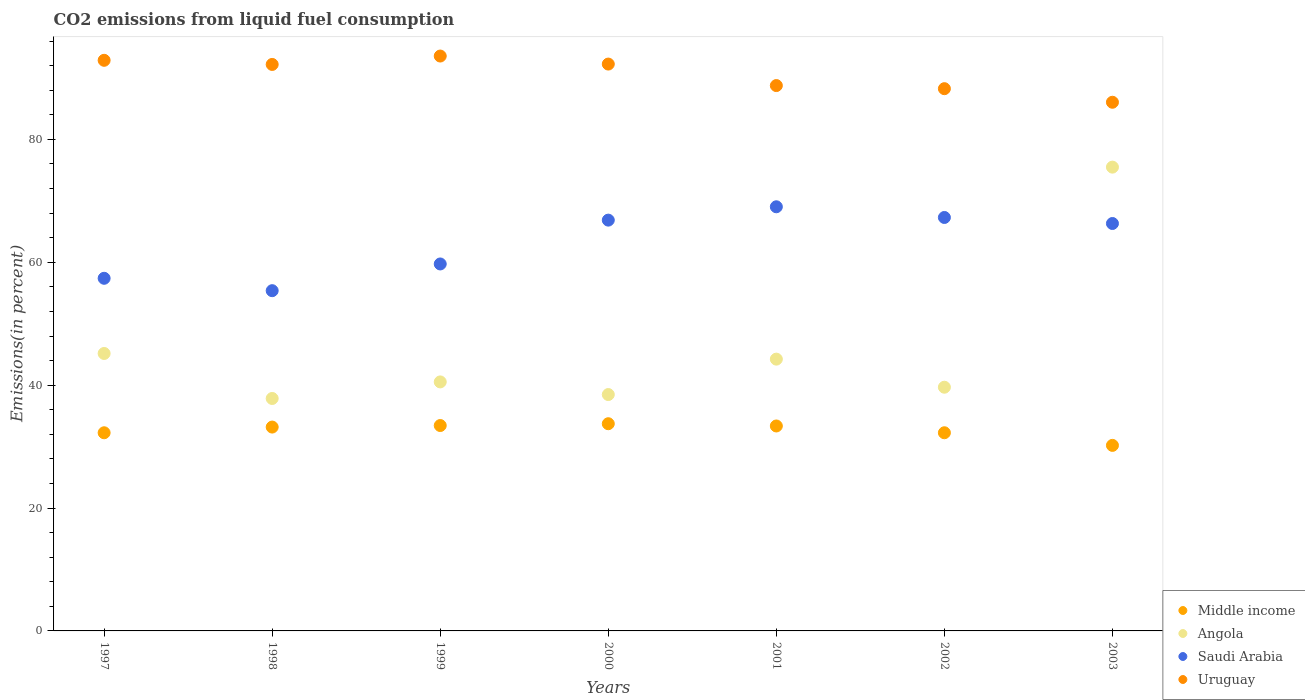How many different coloured dotlines are there?
Provide a succinct answer. 4. What is the total CO2 emitted in Uruguay in 1997?
Make the answer very short. 92.87. Across all years, what is the maximum total CO2 emitted in Angola?
Provide a succinct answer. 75.49. Across all years, what is the minimum total CO2 emitted in Angola?
Keep it short and to the point. 37.83. In which year was the total CO2 emitted in Middle income minimum?
Offer a terse response. 2003. What is the total total CO2 emitted in Angola in the graph?
Keep it short and to the point. 321.37. What is the difference between the total CO2 emitted in Saudi Arabia in 1997 and that in 1998?
Provide a succinct answer. 2.02. What is the difference between the total CO2 emitted in Angola in 1998 and the total CO2 emitted in Uruguay in 2003?
Your response must be concise. -48.21. What is the average total CO2 emitted in Uruguay per year?
Offer a terse response. 90.57. In the year 1998, what is the difference between the total CO2 emitted in Middle income and total CO2 emitted in Angola?
Give a very brief answer. -4.65. In how many years, is the total CO2 emitted in Uruguay greater than 80 %?
Your response must be concise. 7. What is the ratio of the total CO2 emitted in Middle income in 1998 to that in 2001?
Make the answer very short. 0.99. Is the difference between the total CO2 emitted in Middle income in 1998 and 2000 greater than the difference between the total CO2 emitted in Angola in 1998 and 2000?
Offer a very short reply. Yes. What is the difference between the highest and the second highest total CO2 emitted in Uruguay?
Offer a terse response. 0.69. What is the difference between the highest and the lowest total CO2 emitted in Uruguay?
Your answer should be compact. 7.52. In how many years, is the total CO2 emitted in Angola greater than the average total CO2 emitted in Angola taken over all years?
Your answer should be compact. 1. Is the sum of the total CO2 emitted in Angola in 1997 and 2001 greater than the maximum total CO2 emitted in Uruguay across all years?
Your answer should be very brief. No. Is the total CO2 emitted in Saudi Arabia strictly greater than the total CO2 emitted in Angola over the years?
Offer a very short reply. No. How many dotlines are there?
Ensure brevity in your answer.  4. How many years are there in the graph?
Ensure brevity in your answer.  7. What is the difference between two consecutive major ticks on the Y-axis?
Provide a succinct answer. 20. Are the values on the major ticks of Y-axis written in scientific E-notation?
Make the answer very short. No. Does the graph contain any zero values?
Ensure brevity in your answer.  No. Where does the legend appear in the graph?
Your response must be concise. Bottom right. How are the legend labels stacked?
Your answer should be compact. Vertical. What is the title of the graph?
Keep it short and to the point. CO2 emissions from liquid fuel consumption. What is the label or title of the Y-axis?
Keep it short and to the point. Emissions(in percent). What is the Emissions(in percent) of Middle income in 1997?
Your response must be concise. 32.25. What is the Emissions(in percent) of Angola in 1997?
Make the answer very short. 45.16. What is the Emissions(in percent) in Saudi Arabia in 1997?
Make the answer very short. 57.39. What is the Emissions(in percent) in Uruguay in 1997?
Provide a short and direct response. 92.87. What is the Emissions(in percent) in Middle income in 1998?
Make the answer very short. 33.18. What is the Emissions(in percent) in Angola in 1998?
Ensure brevity in your answer.  37.83. What is the Emissions(in percent) in Saudi Arabia in 1998?
Keep it short and to the point. 55.38. What is the Emissions(in percent) of Uruguay in 1998?
Ensure brevity in your answer.  92.2. What is the Emissions(in percent) in Middle income in 1999?
Provide a short and direct response. 33.43. What is the Emissions(in percent) in Angola in 1999?
Offer a terse response. 40.53. What is the Emissions(in percent) in Saudi Arabia in 1999?
Keep it short and to the point. 59.73. What is the Emissions(in percent) of Uruguay in 1999?
Ensure brevity in your answer.  93.57. What is the Emissions(in percent) in Middle income in 2000?
Offer a very short reply. 33.72. What is the Emissions(in percent) of Angola in 2000?
Your response must be concise. 38.47. What is the Emissions(in percent) in Saudi Arabia in 2000?
Your answer should be compact. 66.86. What is the Emissions(in percent) of Uruguay in 2000?
Your response must be concise. 92.26. What is the Emissions(in percent) of Middle income in 2001?
Offer a terse response. 33.36. What is the Emissions(in percent) in Angola in 2001?
Provide a short and direct response. 44.24. What is the Emissions(in percent) in Saudi Arabia in 2001?
Make the answer very short. 69.03. What is the Emissions(in percent) in Uruguay in 2001?
Your answer should be compact. 88.76. What is the Emissions(in percent) of Middle income in 2002?
Your response must be concise. 32.25. What is the Emissions(in percent) of Angola in 2002?
Keep it short and to the point. 39.66. What is the Emissions(in percent) of Saudi Arabia in 2002?
Provide a succinct answer. 67.29. What is the Emissions(in percent) of Uruguay in 2002?
Provide a succinct answer. 88.25. What is the Emissions(in percent) in Middle income in 2003?
Offer a very short reply. 30.2. What is the Emissions(in percent) in Angola in 2003?
Keep it short and to the point. 75.49. What is the Emissions(in percent) of Saudi Arabia in 2003?
Your answer should be very brief. 66.31. What is the Emissions(in percent) in Uruguay in 2003?
Your answer should be very brief. 86.04. Across all years, what is the maximum Emissions(in percent) in Middle income?
Your response must be concise. 33.72. Across all years, what is the maximum Emissions(in percent) of Angola?
Your response must be concise. 75.49. Across all years, what is the maximum Emissions(in percent) of Saudi Arabia?
Your response must be concise. 69.03. Across all years, what is the maximum Emissions(in percent) in Uruguay?
Provide a succinct answer. 93.57. Across all years, what is the minimum Emissions(in percent) in Middle income?
Your answer should be compact. 30.2. Across all years, what is the minimum Emissions(in percent) of Angola?
Provide a succinct answer. 37.83. Across all years, what is the minimum Emissions(in percent) in Saudi Arabia?
Offer a very short reply. 55.38. Across all years, what is the minimum Emissions(in percent) of Uruguay?
Offer a very short reply. 86.04. What is the total Emissions(in percent) of Middle income in the graph?
Offer a very short reply. 228.39. What is the total Emissions(in percent) of Angola in the graph?
Offer a terse response. 321.37. What is the total Emissions(in percent) of Saudi Arabia in the graph?
Give a very brief answer. 441.99. What is the total Emissions(in percent) of Uruguay in the graph?
Provide a short and direct response. 633.96. What is the difference between the Emissions(in percent) in Middle income in 1997 and that in 1998?
Give a very brief answer. -0.93. What is the difference between the Emissions(in percent) of Angola in 1997 and that in 1998?
Your response must be concise. 7.32. What is the difference between the Emissions(in percent) in Saudi Arabia in 1997 and that in 1998?
Provide a short and direct response. 2.02. What is the difference between the Emissions(in percent) of Uruguay in 1997 and that in 1998?
Keep it short and to the point. 0.67. What is the difference between the Emissions(in percent) in Middle income in 1997 and that in 1999?
Give a very brief answer. -1.18. What is the difference between the Emissions(in percent) in Angola in 1997 and that in 1999?
Provide a succinct answer. 4.63. What is the difference between the Emissions(in percent) in Saudi Arabia in 1997 and that in 1999?
Offer a very short reply. -2.33. What is the difference between the Emissions(in percent) in Uruguay in 1997 and that in 1999?
Provide a succinct answer. -0.69. What is the difference between the Emissions(in percent) of Middle income in 1997 and that in 2000?
Provide a succinct answer. -1.47. What is the difference between the Emissions(in percent) in Angola in 1997 and that in 2000?
Your answer should be compact. 6.69. What is the difference between the Emissions(in percent) of Saudi Arabia in 1997 and that in 2000?
Your response must be concise. -9.47. What is the difference between the Emissions(in percent) in Uruguay in 1997 and that in 2000?
Make the answer very short. 0.61. What is the difference between the Emissions(in percent) in Middle income in 1997 and that in 2001?
Provide a short and direct response. -1.1. What is the difference between the Emissions(in percent) of Angola in 1997 and that in 2001?
Provide a succinct answer. 0.92. What is the difference between the Emissions(in percent) of Saudi Arabia in 1997 and that in 2001?
Your response must be concise. -11.64. What is the difference between the Emissions(in percent) of Uruguay in 1997 and that in 2001?
Your response must be concise. 4.11. What is the difference between the Emissions(in percent) of Middle income in 1997 and that in 2002?
Offer a terse response. -0. What is the difference between the Emissions(in percent) in Angola in 1997 and that in 2002?
Make the answer very short. 5.49. What is the difference between the Emissions(in percent) in Saudi Arabia in 1997 and that in 2002?
Give a very brief answer. -9.9. What is the difference between the Emissions(in percent) of Uruguay in 1997 and that in 2002?
Your answer should be very brief. 4.62. What is the difference between the Emissions(in percent) of Middle income in 1997 and that in 2003?
Offer a terse response. 2.05. What is the difference between the Emissions(in percent) in Angola in 1997 and that in 2003?
Make the answer very short. -30.33. What is the difference between the Emissions(in percent) of Saudi Arabia in 1997 and that in 2003?
Provide a short and direct response. -8.92. What is the difference between the Emissions(in percent) of Uruguay in 1997 and that in 2003?
Keep it short and to the point. 6.83. What is the difference between the Emissions(in percent) in Middle income in 1998 and that in 1999?
Your answer should be compact. -0.25. What is the difference between the Emissions(in percent) in Angola in 1998 and that in 1999?
Keep it short and to the point. -2.7. What is the difference between the Emissions(in percent) of Saudi Arabia in 1998 and that in 1999?
Provide a short and direct response. -4.35. What is the difference between the Emissions(in percent) in Uruguay in 1998 and that in 1999?
Ensure brevity in your answer.  -1.37. What is the difference between the Emissions(in percent) in Middle income in 1998 and that in 2000?
Offer a very short reply. -0.55. What is the difference between the Emissions(in percent) in Angola in 1998 and that in 2000?
Ensure brevity in your answer.  -0.64. What is the difference between the Emissions(in percent) in Saudi Arabia in 1998 and that in 2000?
Offer a very short reply. -11.48. What is the difference between the Emissions(in percent) of Uruguay in 1998 and that in 2000?
Make the answer very short. -0.06. What is the difference between the Emissions(in percent) of Middle income in 1998 and that in 2001?
Your answer should be very brief. -0.18. What is the difference between the Emissions(in percent) in Angola in 1998 and that in 2001?
Offer a very short reply. -6.4. What is the difference between the Emissions(in percent) in Saudi Arabia in 1998 and that in 2001?
Make the answer very short. -13.65. What is the difference between the Emissions(in percent) of Uruguay in 1998 and that in 2001?
Make the answer very short. 3.44. What is the difference between the Emissions(in percent) in Middle income in 1998 and that in 2002?
Your response must be concise. 0.93. What is the difference between the Emissions(in percent) in Angola in 1998 and that in 2002?
Provide a succinct answer. -1.83. What is the difference between the Emissions(in percent) of Saudi Arabia in 1998 and that in 2002?
Your answer should be compact. -11.91. What is the difference between the Emissions(in percent) in Uruguay in 1998 and that in 2002?
Give a very brief answer. 3.94. What is the difference between the Emissions(in percent) of Middle income in 1998 and that in 2003?
Provide a succinct answer. 2.98. What is the difference between the Emissions(in percent) of Angola in 1998 and that in 2003?
Your answer should be very brief. -37.65. What is the difference between the Emissions(in percent) in Saudi Arabia in 1998 and that in 2003?
Ensure brevity in your answer.  -10.93. What is the difference between the Emissions(in percent) in Uruguay in 1998 and that in 2003?
Give a very brief answer. 6.15. What is the difference between the Emissions(in percent) of Middle income in 1999 and that in 2000?
Your answer should be compact. -0.29. What is the difference between the Emissions(in percent) of Angola in 1999 and that in 2000?
Your answer should be very brief. 2.06. What is the difference between the Emissions(in percent) of Saudi Arabia in 1999 and that in 2000?
Offer a terse response. -7.13. What is the difference between the Emissions(in percent) in Uruguay in 1999 and that in 2000?
Make the answer very short. 1.31. What is the difference between the Emissions(in percent) of Middle income in 1999 and that in 2001?
Give a very brief answer. 0.07. What is the difference between the Emissions(in percent) in Angola in 1999 and that in 2001?
Your response must be concise. -3.71. What is the difference between the Emissions(in percent) in Saudi Arabia in 1999 and that in 2001?
Give a very brief answer. -9.31. What is the difference between the Emissions(in percent) of Uruguay in 1999 and that in 2001?
Give a very brief answer. 4.81. What is the difference between the Emissions(in percent) of Middle income in 1999 and that in 2002?
Provide a short and direct response. 1.18. What is the difference between the Emissions(in percent) in Angola in 1999 and that in 2002?
Offer a very short reply. 0.86. What is the difference between the Emissions(in percent) of Saudi Arabia in 1999 and that in 2002?
Keep it short and to the point. -7.57. What is the difference between the Emissions(in percent) in Uruguay in 1999 and that in 2002?
Provide a short and direct response. 5.31. What is the difference between the Emissions(in percent) in Middle income in 1999 and that in 2003?
Offer a terse response. 3.23. What is the difference between the Emissions(in percent) in Angola in 1999 and that in 2003?
Provide a succinct answer. -34.96. What is the difference between the Emissions(in percent) in Saudi Arabia in 1999 and that in 2003?
Keep it short and to the point. -6.59. What is the difference between the Emissions(in percent) in Uruguay in 1999 and that in 2003?
Provide a short and direct response. 7.52. What is the difference between the Emissions(in percent) of Middle income in 2000 and that in 2001?
Keep it short and to the point. 0.37. What is the difference between the Emissions(in percent) in Angola in 2000 and that in 2001?
Your response must be concise. -5.76. What is the difference between the Emissions(in percent) in Saudi Arabia in 2000 and that in 2001?
Keep it short and to the point. -2.17. What is the difference between the Emissions(in percent) of Uruguay in 2000 and that in 2001?
Ensure brevity in your answer.  3.5. What is the difference between the Emissions(in percent) in Middle income in 2000 and that in 2002?
Provide a short and direct response. 1.47. What is the difference between the Emissions(in percent) of Angola in 2000 and that in 2002?
Give a very brief answer. -1.19. What is the difference between the Emissions(in percent) in Saudi Arabia in 2000 and that in 2002?
Provide a succinct answer. -0.43. What is the difference between the Emissions(in percent) of Uruguay in 2000 and that in 2002?
Make the answer very short. 4.01. What is the difference between the Emissions(in percent) of Middle income in 2000 and that in 2003?
Your answer should be very brief. 3.53. What is the difference between the Emissions(in percent) of Angola in 2000 and that in 2003?
Offer a very short reply. -37.02. What is the difference between the Emissions(in percent) in Saudi Arabia in 2000 and that in 2003?
Offer a terse response. 0.55. What is the difference between the Emissions(in percent) of Uruguay in 2000 and that in 2003?
Your answer should be compact. 6.22. What is the difference between the Emissions(in percent) of Middle income in 2001 and that in 2002?
Keep it short and to the point. 1.1. What is the difference between the Emissions(in percent) of Angola in 2001 and that in 2002?
Offer a terse response. 4.57. What is the difference between the Emissions(in percent) of Saudi Arabia in 2001 and that in 2002?
Make the answer very short. 1.74. What is the difference between the Emissions(in percent) in Uruguay in 2001 and that in 2002?
Give a very brief answer. 0.51. What is the difference between the Emissions(in percent) of Middle income in 2001 and that in 2003?
Give a very brief answer. 3.16. What is the difference between the Emissions(in percent) in Angola in 2001 and that in 2003?
Make the answer very short. -31.25. What is the difference between the Emissions(in percent) of Saudi Arabia in 2001 and that in 2003?
Offer a very short reply. 2.72. What is the difference between the Emissions(in percent) of Uruguay in 2001 and that in 2003?
Your response must be concise. 2.72. What is the difference between the Emissions(in percent) of Middle income in 2002 and that in 2003?
Make the answer very short. 2.05. What is the difference between the Emissions(in percent) in Angola in 2002 and that in 2003?
Provide a succinct answer. -35.82. What is the difference between the Emissions(in percent) of Saudi Arabia in 2002 and that in 2003?
Offer a very short reply. 0.98. What is the difference between the Emissions(in percent) of Uruguay in 2002 and that in 2003?
Your answer should be very brief. 2.21. What is the difference between the Emissions(in percent) of Middle income in 1997 and the Emissions(in percent) of Angola in 1998?
Ensure brevity in your answer.  -5.58. What is the difference between the Emissions(in percent) of Middle income in 1997 and the Emissions(in percent) of Saudi Arabia in 1998?
Ensure brevity in your answer.  -23.13. What is the difference between the Emissions(in percent) of Middle income in 1997 and the Emissions(in percent) of Uruguay in 1998?
Give a very brief answer. -59.95. What is the difference between the Emissions(in percent) of Angola in 1997 and the Emissions(in percent) of Saudi Arabia in 1998?
Provide a succinct answer. -10.22. What is the difference between the Emissions(in percent) in Angola in 1997 and the Emissions(in percent) in Uruguay in 1998?
Ensure brevity in your answer.  -47.04. What is the difference between the Emissions(in percent) in Saudi Arabia in 1997 and the Emissions(in percent) in Uruguay in 1998?
Provide a succinct answer. -34.81. What is the difference between the Emissions(in percent) in Middle income in 1997 and the Emissions(in percent) in Angola in 1999?
Provide a short and direct response. -8.28. What is the difference between the Emissions(in percent) of Middle income in 1997 and the Emissions(in percent) of Saudi Arabia in 1999?
Keep it short and to the point. -27.47. What is the difference between the Emissions(in percent) of Middle income in 1997 and the Emissions(in percent) of Uruguay in 1999?
Your answer should be compact. -61.31. What is the difference between the Emissions(in percent) in Angola in 1997 and the Emissions(in percent) in Saudi Arabia in 1999?
Make the answer very short. -14.57. What is the difference between the Emissions(in percent) of Angola in 1997 and the Emissions(in percent) of Uruguay in 1999?
Ensure brevity in your answer.  -48.41. What is the difference between the Emissions(in percent) of Saudi Arabia in 1997 and the Emissions(in percent) of Uruguay in 1999?
Ensure brevity in your answer.  -36.17. What is the difference between the Emissions(in percent) in Middle income in 1997 and the Emissions(in percent) in Angola in 2000?
Provide a short and direct response. -6.22. What is the difference between the Emissions(in percent) of Middle income in 1997 and the Emissions(in percent) of Saudi Arabia in 2000?
Offer a terse response. -34.61. What is the difference between the Emissions(in percent) in Middle income in 1997 and the Emissions(in percent) in Uruguay in 2000?
Ensure brevity in your answer.  -60.01. What is the difference between the Emissions(in percent) of Angola in 1997 and the Emissions(in percent) of Saudi Arabia in 2000?
Provide a succinct answer. -21.7. What is the difference between the Emissions(in percent) of Angola in 1997 and the Emissions(in percent) of Uruguay in 2000?
Keep it short and to the point. -47.1. What is the difference between the Emissions(in percent) in Saudi Arabia in 1997 and the Emissions(in percent) in Uruguay in 2000?
Your answer should be very brief. -34.87. What is the difference between the Emissions(in percent) in Middle income in 1997 and the Emissions(in percent) in Angola in 2001?
Your response must be concise. -11.98. What is the difference between the Emissions(in percent) of Middle income in 1997 and the Emissions(in percent) of Saudi Arabia in 2001?
Your answer should be very brief. -36.78. What is the difference between the Emissions(in percent) in Middle income in 1997 and the Emissions(in percent) in Uruguay in 2001?
Your answer should be compact. -56.51. What is the difference between the Emissions(in percent) of Angola in 1997 and the Emissions(in percent) of Saudi Arabia in 2001?
Keep it short and to the point. -23.88. What is the difference between the Emissions(in percent) of Angola in 1997 and the Emissions(in percent) of Uruguay in 2001?
Offer a terse response. -43.6. What is the difference between the Emissions(in percent) of Saudi Arabia in 1997 and the Emissions(in percent) of Uruguay in 2001?
Your answer should be compact. -31.37. What is the difference between the Emissions(in percent) of Middle income in 1997 and the Emissions(in percent) of Angola in 2002?
Provide a succinct answer. -7.41. What is the difference between the Emissions(in percent) of Middle income in 1997 and the Emissions(in percent) of Saudi Arabia in 2002?
Provide a short and direct response. -35.04. What is the difference between the Emissions(in percent) of Middle income in 1997 and the Emissions(in percent) of Uruguay in 2002?
Your response must be concise. -56. What is the difference between the Emissions(in percent) in Angola in 1997 and the Emissions(in percent) in Saudi Arabia in 2002?
Your response must be concise. -22.13. What is the difference between the Emissions(in percent) of Angola in 1997 and the Emissions(in percent) of Uruguay in 2002?
Provide a succinct answer. -43.1. What is the difference between the Emissions(in percent) of Saudi Arabia in 1997 and the Emissions(in percent) of Uruguay in 2002?
Offer a terse response. -30.86. What is the difference between the Emissions(in percent) in Middle income in 1997 and the Emissions(in percent) in Angola in 2003?
Offer a very short reply. -43.23. What is the difference between the Emissions(in percent) of Middle income in 1997 and the Emissions(in percent) of Saudi Arabia in 2003?
Your response must be concise. -34.06. What is the difference between the Emissions(in percent) of Middle income in 1997 and the Emissions(in percent) of Uruguay in 2003?
Make the answer very short. -53.79. What is the difference between the Emissions(in percent) in Angola in 1997 and the Emissions(in percent) in Saudi Arabia in 2003?
Provide a short and direct response. -21.15. What is the difference between the Emissions(in percent) of Angola in 1997 and the Emissions(in percent) of Uruguay in 2003?
Your response must be concise. -40.89. What is the difference between the Emissions(in percent) in Saudi Arabia in 1997 and the Emissions(in percent) in Uruguay in 2003?
Keep it short and to the point. -28.65. What is the difference between the Emissions(in percent) of Middle income in 1998 and the Emissions(in percent) of Angola in 1999?
Offer a very short reply. -7.35. What is the difference between the Emissions(in percent) of Middle income in 1998 and the Emissions(in percent) of Saudi Arabia in 1999?
Your answer should be very brief. -26.55. What is the difference between the Emissions(in percent) in Middle income in 1998 and the Emissions(in percent) in Uruguay in 1999?
Ensure brevity in your answer.  -60.39. What is the difference between the Emissions(in percent) in Angola in 1998 and the Emissions(in percent) in Saudi Arabia in 1999?
Provide a succinct answer. -21.89. What is the difference between the Emissions(in percent) of Angola in 1998 and the Emissions(in percent) of Uruguay in 1999?
Offer a very short reply. -55.73. What is the difference between the Emissions(in percent) of Saudi Arabia in 1998 and the Emissions(in percent) of Uruguay in 1999?
Offer a very short reply. -38.19. What is the difference between the Emissions(in percent) in Middle income in 1998 and the Emissions(in percent) in Angola in 2000?
Give a very brief answer. -5.29. What is the difference between the Emissions(in percent) of Middle income in 1998 and the Emissions(in percent) of Saudi Arabia in 2000?
Offer a terse response. -33.68. What is the difference between the Emissions(in percent) in Middle income in 1998 and the Emissions(in percent) in Uruguay in 2000?
Give a very brief answer. -59.08. What is the difference between the Emissions(in percent) of Angola in 1998 and the Emissions(in percent) of Saudi Arabia in 2000?
Offer a terse response. -29.03. What is the difference between the Emissions(in percent) in Angola in 1998 and the Emissions(in percent) in Uruguay in 2000?
Keep it short and to the point. -54.43. What is the difference between the Emissions(in percent) of Saudi Arabia in 1998 and the Emissions(in percent) of Uruguay in 2000?
Your answer should be compact. -36.88. What is the difference between the Emissions(in percent) of Middle income in 1998 and the Emissions(in percent) of Angola in 2001?
Your answer should be very brief. -11.06. What is the difference between the Emissions(in percent) of Middle income in 1998 and the Emissions(in percent) of Saudi Arabia in 2001?
Give a very brief answer. -35.85. What is the difference between the Emissions(in percent) of Middle income in 1998 and the Emissions(in percent) of Uruguay in 2001?
Offer a terse response. -55.58. What is the difference between the Emissions(in percent) in Angola in 1998 and the Emissions(in percent) in Saudi Arabia in 2001?
Your response must be concise. -31.2. What is the difference between the Emissions(in percent) of Angola in 1998 and the Emissions(in percent) of Uruguay in 2001?
Ensure brevity in your answer.  -50.93. What is the difference between the Emissions(in percent) in Saudi Arabia in 1998 and the Emissions(in percent) in Uruguay in 2001?
Your response must be concise. -33.38. What is the difference between the Emissions(in percent) of Middle income in 1998 and the Emissions(in percent) of Angola in 2002?
Your response must be concise. -6.49. What is the difference between the Emissions(in percent) of Middle income in 1998 and the Emissions(in percent) of Saudi Arabia in 2002?
Offer a very short reply. -34.11. What is the difference between the Emissions(in percent) in Middle income in 1998 and the Emissions(in percent) in Uruguay in 2002?
Your answer should be compact. -55.08. What is the difference between the Emissions(in percent) of Angola in 1998 and the Emissions(in percent) of Saudi Arabia in 2002?
Your answer should be compact. -29.46. What is the difference between the Emissions(in percent) in Angola in 1998 and the Emissions(in percent) in Uruguay in 2002?
Ensure brevity in your answer.  -50.42. What is the difference between the Emissions(in percent) in Saudi Arabia in 1998 and the Emissions(in percent) in Uruguay in 2002?
Your answer should be very brief. -32.88. What is the difference between the Emissions(in percent) of Middle income in 1998 and the Emissions(in percent) of Angola in 2003?
Offer a very short reply. -42.31. What is the difference between the Emissions(in percent) in Middle income in 1998 and the Emissions(in percent) in Saudi Arabia in 2003?
Give a very brief answer. -33.13. What is the difference between the Emissions(in percent) in Middle income in 1998 and the Emissions(in percent) in Uruguay in 2003?
Keep it short and to the point. -52.87. What is the difference between the Emissions(in percent) of Angola in 1998 and the Emissions(in percent) of Saudi Arabia in 2003?
Provide a succinct answer. -28.48. What is the difference between the Emissions(in percent) of Angola in 1998 and the Emissions(in percent) of Uruguay in 2003?
Your answer should be very brief. -48.21. What is the difference between the Emissions(in percent) of Saudi Arabia in 1998 and the Emissions(in percent) of Uruguay in 2003?
Keep it short and to the point. -30.67. What is the difference between the Emissions(in percent) in Middle income in 1999 and the Emissions(in percent) in Angola in 2000?
Your response must be concise. -5.04. What is the difference between the Emissions(in percent) in Middle income in 1999 and the Emissions(in percent) in Saudi Arabia in 2000?
Make the answer very short. -33.43. What is the difference between the Emissions(in percent) in Middle income in 1999 and the Emissions(in percent) in Uruguay in 2000?
Give a very brief answer. -58.83. What is the difference between the Emissions(in percent) in Angola in 1999 and the Emissions(in percent) in Saudi Arabia in 2000?
Ensure brevity in your answer.  -26.33. What is the difference between the Emissions(in percent) in Angola in 1999 and the Emissions(in percent) in Uruguay in 2000?
Your answer should be very brief. -51.73. What is the difference between the Emissions(in percent) in Saudi Arabia in 1999 and the Emissions(in percent) in Uruguay in 2000?
Ensure brevity in your answer.  -32.53. What is the difference between the Emissions(in percent) of Middle income in 1999 and the Emissions(in percent) of Angola in 2001?
Give a very brief answer. -10.81. What is the difference between the Emissions(in percent) in Middle income in 1999 and the Emissions(in percent) in Saudi Arabia in 2001?
Keep it short and to the point. -35.6. What is the difference between the Emissions(in percent) of Middle income in 1999 and the Emissions(in percent) of Uruguay in 2001?
Offer a very short reply. -55.33. What is the difference between the Emissions(in percent) of Angola in 1999 and the Emissions(in percent) of Saudi Arabia in 2001?
Offer a very short reply. -28.5. What is the difference between the Emissions(in percent) in Angola in 1999 and the Emissions(in percent) in Uruguay in 2001?
Offer a terse response. -48.23. What is the difference between the Emissions(in percent) of Saudi Arabia in 1999 and the Emissions(in percent) of Uruguay in 2001?
Your answer should be very brief. -29.04. What is the difference between the Emissions(in percent) of Middle income in 1999 and the Emissions(in percent) of Angola in 2002?
Keep it short and to the point. -6.23. What is the difference between the Emissions(in percent) of Middle income in 1999 and the Emissions(in percent) of Saudi Arabia in 2002?
Provide a succinct answer. -33.86. What is the difference between the Emissions(in percent) in Middle income in 1999 and the Emissions(in percent) in Uruguay in 2002?
Give a very brief answer. -54.82. What is the difference between the Emissions(in percent) in Angola in 1999 and the Emissions(in percent) in Saudi Arabia in 2002?
Ensure brevity in your answer.  -26.76. What is the difference between the Emissions(in percent) in Angola in 1999 and the Emissions(in percent) in Uruguay in 2002?
Your response must be concise. -47.73. What is the difference between the Emissions(in percent) in Saudi Arabia in 1999 and the Emissions(in percent) in Uruguay in 2002?
Your response must be concise. -28.53. What is the difference between the Emissions(in percent) in Middle income in 1999 and the Emissions(in percent) in Angola in 2003?
Offer a very short reply. -42.06. What is the difference between the Emissions(in percent) of Middle income in 1999 and the Emissions(in percent) of Saudi Arabia in 2003?
Offer a terse response. -32.88. What is the difference between the Emissions(in percent) of Middle income in 1999 and the Emissions(in percent) of Uruguay in 2003?
Offer a very short reply. -52.62. What is the difference between the Emissions(in percent) of Angola in 1999 and the Emissions(in percent) of Saudi Arabia in 2003?
Ensure brevity in your answer.  -25.78. What is the difference between the Emissions(in percent) in Angola in 1999 and the Emissions(in percent) in Uruguay in 2003?
Your response must be concise. -45.52. What is the difference between the Emissions(in percent) in Saudi Arabia in 1999 and the Emissions(in percent) in Uruguay in 2003?
Your answer should be very brief. -26.32. What is the difference between the Emissions(in percent) of Middle income in 2000 and the Emissions(in percent) of Angola in 2001?
Provide a succinct answer. -10.51. What is the difference between the Emissions(in percent) in Middle income in 2000 and the Emissions(in percent) in Saudi Arabia in 2001?
Provide a short and direct response. -35.31. What is the difference between the Emissions(in percent) of Middle income in 2000 and the Emissions(in percent) of Uruguay in 2001?
Offer a terse response. -55.04. What is the difference between the Emissions(in percent) of Angola in 2000 and the Emissions(in percent) of Saudi Arabia in 2001?
Ensure brevity in your answer.  -30.56. What is the difference between the Emissions(in percent) in Angola in 2000 and the Emissions(in percent) in Uruguay in 2001?
Your answer should be very brief. -50.29. What is the difference between the Emissions(in percent) of Saudi Arabia in 2000 and the Emissions(in percent) of Uruguay in 2001?
Offer a terse response. -21.9. What is the difference between the Emissions(in percent) of Middle income in 2000 and the Emissions(in percent) of Angola in 2002?
Ensure brevity in your answer.  -5.94. What is the difference between the Emissions(in percent) in Middle income in 2000 and the Emissions(in percent) in Saudi Arabia in 2002?
Give a very brief answer. -33.57. What is the difference between the Emissions(in percent) of Middle income in 2000 and the Emissions(in percent) of Uruguay in 2002?
Your response must be concise. -54.53. What is the difference between the Emissions(in percent) of Angola in 2000 and the Emissions(in percent) of Saudi Arabia in 2002?
Provide a short and direct response. -28.82. What is the difference between the Emissions(in percent) in Angola in 2000 and the Emissions(in percent) in Uruguay in 2002?
Give a very brief answer. -49.78. What is the difference between the Emissions(in percent) in Saudi Arabia in 2000 and the Emissions(in percent) in Uruguay in 2002?
Offer a terse response. -21.39. What is the difference between the Emissions(in percent) in Middle income in 2000 and the Emissions(in percent) in Angola in 2003?
Provide a succinct answer. -41.76. What is the difference between the Emissions(in percent) in Middle income in 2000 and the Emissions(in percent) in Saudi Arabia in 2003?
Your answer should be compact. -32.59. What is the difference between the Emissions(in percent) of Middle income in 2000 and the Emissions(in percent) of Uruguay in 2003?
Your answer should be very brief. -52.32. What is the difference between the Emissions(in percent) in Angola in 2000 and the Emissions(in percent) in Saudi Arabia in 2003?
Ensure brevity in your answer.  -27.84. What is the difference between the Emissions(in percent) in Angola in 2000 and the Emissions(in percent) in Uruguay in 2003?
Your response must be concise. -47.57. What is the difference between the Emissions(in percent) in Saudi Arabia in 2000 and the Emissions(in percent) in Uruguay in 2003?
Give a very brief answer. -19.18. What is the difference between the Emissions(in percent) in Middle income in 2001 and the Emissions(in percent) in Angola in 2002?
Offer a terse response. -6.31. What is the difference between the Emissions(in percent) in Middle income in 2001 and the Emissions(in percent) in Saudi Arabia in 2002?
Your answer should be very brief. -33.94. What is the difference between the Emissions(in percent) of Middle income in 2001 and the Emissions(in percent) of Uruguay in 2002?
Keep it short and to the point. -54.9. What is the difference between the Emissions(in percent) of Angola in 2001 and the Emissions(in percent) of Saudi Arabia in 2002?
Your answer should be very brief. -23.06. What is the difference between the Emissions(in percent) in Angola in 2001 and the Emissions(in percent) in Uruguay in 2002?
Ensure brevity in your answer.  -44.02. What is the difference between the Emissions(in percent) in Saudi Arabia in 2001 and the Emissions(in percent) in Uruguay in 2002?
Your response must be concise. -19.22. What is the difference between the Emissions(in percent) of Middle income in 2001 and the Emissions(in percent) of Angola in 2003?
Make the answer very short. -42.13. What is the difference between the Emissions(in percent) of Middle income in 2001 and the Emissions(in percent) of Saudi Arabia in 2003?
Keep it short and to the point. -32.95. What is the difference between the Emissions(in percent) in Middle income in 2001 and the Emissions(in percent) in Uruguay in 2003?
Your answer should be very brief. -52.69. What is the difference between the Emissions(in percent) of Angola in 2001 and the Emissions(in percent) of Saudi Arabia in 2003?
Keep it short and to the point. -22.08. What is the difference between the Emissions(in percent) of Angola in 2001 and the Emissions(in percent) of Uruguay in 2003?
Offer a terse response. -41.81. What is the difference between the Emissions(in percent) in Saudi Arabia in 2001 and the Emissions(in percent) in Uruguay in 2003?
Your answer should be compact. -17.01. What is the difference between the Emissions(in percent) of Middle income in 2002 and the Emissions(in percent) of Angola in 2003?
Provide a short and direct response. -43.23. What is the difference between the Emissions(in percent) in Middle income in 2002 and the Emissions(in percent) in Saudi Arabia in 2003?
Keep it short and to the point. -34.06. What is the difference between the Emissions(in percent) in Middle income in 2002 and the Emissions(in percent) in Uruguay in 2003?
Your answer should be compact. -53.79. What is the difference between the Emissions(in percent) in Angola in 2002 and the Emissions(in percent) in Saudi Arabia in 2003?
Your answer should be compact. -26.65. What is the difference between the Emissions(in percent) of Angola in 2002 and the Emissions(in percent) of Uruguay in 2003?
Your response must be concise. -46.38. What is the difference between the Emissions(in percent) of Saudi Arabia in 2002 and the Emissions(in percent) of Uruguay in 2003?
Give a very brief answer. -18.75. What is the average Emissions(in percent) in Middle income per year?
Give a very brief answer. 32.63. What is the average Emissions(in percent) of Angola per year?
Provide a short and direct response. 45.91. What is the average Emissions(in percent) of Saudi Arabia per year?
Ensure brevity in your answer.  63.14. What is the average Emissions(in percent) of Uruguay per year?
Keep it short and to the point. 90.56. In the year 1997, what is the difference between the Emissions(in percent) of Middle income and Emissions(in percent) of Angola?
Ensure brevity in your answer.  -12.91. In the year 1997, what is the difference between the Emissions(in percent) in Middle income and Emissions(in percent) in Saudi Arabia?
Your response must be concise. -25.14. In the year 1997, what is the difference between the Emissions(in percent) of Middle income and Emissions(in percent) of Uruguay?
Keep it short and to the point. -60.62. In the year 1997, what is the difference between the Emissions(in percent) of Angola and Emissions(in percent) of Saudi Arabia?
Offer a very short reply. -12.24. In the year 1997, what is the difference between the Emissions(in percent) of Angola and Emissions(in percent) of Uruguay?
Offer a terse response. -47.71. In the year 1997, what is the difference between the Emissions(in percent) in Saudi Arabia and Emissions(in percent) in Uruguay?
Provide a succinct answer. -35.48. In the year 1998, what is the difference between the Emissions(in percent) of Middle income and Emissions(in percent) of Angola?
Offer a terse response. -4.65. In the year 1998, what is the difference between the Emissions(in percent) in Middle income and Emissions(in percent) in Saudi Arabia?
Provide a succinct answer. -22.2. In the year 1998, what is the difference between the Emissions(in percent) in Middle income and Emissions(in percent) in Uruguay?
Offer a very short reply. -59.02. In the year 1998, what is the difference between the Emissions(in percent) of Angola and Emissions(in percent) of Saudi Arabia?
Keep it short and to the point. -17.55. In the year 1998, what is the difference between the Emissions(in percent) in Angola and Emissions(in percent) in Uruguay?
Make the answer very short. -54.37. In the year 1998, what is the difference between the Emissions(in percent) in Saudi Arabia and Emissions(in percent) in Uruguay?
Give a very brief answer. -36.82. In the year 1999, what is the difference between the Emissions(in percent) in Middle income and Emissions(in percent) in Angola?
Provide a succinct answer. -7.1. In the year 1999, what is the difference between the Emissions(in percent) in Middle income and Emissions(in percent) in Saudi Arabia?
Make the answer very short. -26.3. In the year 1999, what is the difference between the Emissions(in percent) of Middle income and Emissions(in percent) of Uruguay?
Offer a very short reply. -60.14. In the year 1999, what is the difference between the Emissions(in percent) of Angola and Emissions(in percent) of Saudi Arabia?
Make the answer very short. -19.2. In the year 1999, what is the difference between the Emissions(in percent) of Angola and Emissions(in percent) of Uruguay?
Keep it short and to the point. -53.04. In the year 1999, what is the difference between the Emissions(in percent) in Saudi Arabia and Emissions(in percent) in Uruguay?
Ensure brevity in your answer.  -33.84. In the year 2000, what is the difference between the Emissions(in percent) in Middle income and Emissions(in percent) in Angola?
Your answer should be very brief. -4.75. In the year 2000, what is the difference between the Emissions(in percent) in Middle income and Emissions(in percent) in Saudi Arabia?
Offer a very short reply. -33.14. In the year 2000, what is the difference between the Emissions(in percent) of Middle income and Emissions(in percent) of Uruguay?
Give a very brief answer. -58.54. In the year 2000, what is the difference between the Emissions(in percent) in Angola and Emissions(in percent) in Saudi Arabia?
Make the answer very short. -28.39. In the year 2000, what is the difference between the Emissions(in percent) of Angola and Emissions(in percent) of Uruguay?
Offer a very short reply. -53.79. In the year 2000, what is the difference between the Emissions(in percent) of Saudi Arabia and Emissions(in percent) of Uruguay?
Offer a terse response. -25.4. In the year 2001, what is the difference between the Emissions(in percent) in Middle income and Emissions(in percent) in Angola?
Provide a succinct answer. -10.88. In the year 2001, what is the difference between the Emissions(in percent) of Middle income and Emissions(in percent) of Saudi Arabia?
Provide a short and direct response. -35.68. In the year 2001, what is the difference between the Emissions(in percent) in Middle income and Emissions(in percent) in Uruguay?
Provide a succinct answer. -55.4. In the year 2001, what is the difference between the Emissions(in percent) of Angola and Emissions(in percent) of Saudi Arabia?
Keep it short and to the point. -24.8. In the year 2001, what is the difference between the Emissions(in percent) of Angola and Emissions(in percent) of Uruguay?
Give a very brief answer. -44.53. In the year 2001, what is the difference between the Emissions(in percent) in Saudi Arabia and Emissions(in percent) in Uruguay?
Your response must be concise. -19.73. In the year 2002, what is the difference between the Emissions(in percent) of Middle income and Emissions(in percent) of Angola?
Make the answer very short. -7.41. In the year 2002, what is the difference between the Emissions(in percent) in Middle income and Emissions(in percent) in Saudi Arabia?
Offer a terse response. -35.04. In the year 2002, what is the difference between the Emissions(in percent) in Middle income and Emissions(in percent) in Uruguay?
Provide a succinct answer. -56. In the year 2002, what is the difference between the Emissions(in percent) in Angola and Emissions(in percent) in Saudi Arabia?
Keep it short and to the point. -27.63. In the year 2002, what is the difference between the Emissions(in percent) of Angola and Emissions(in percent) of Uruguay?
Provide a short and direct response. -48.59. In the year 2002, what is the difference between the Emissions(in percent) in Saudi Arabia and Emissions(in percent) in Uruguay?
Offer a terse response. -20.96. In the year 2003, what is the difference between the Emissions(in percent) of Middle income and Emissions(in percent) of Angola?
Your answer should be very brief. -45.29. In the year 2003, what is the difference between the Emissions(in percent) of Middle income and Emissions(in percent) of Saudi Arabia?
Provide a succinct answer. -36.11. In the year 2003, what is the difference between the Emissions(in percent) of Middle income and Emissions(in percent) of Uruguay?
Offer a very short reply. -55.85. In the year 2003, what is the difference between the Emissions(in percent) in Angola and Emissions(in percent) in Saudi Arabia?
Your answer should be very brief. 9.17. In the year 2003, what is the difference between the Emissions(in percent) of Angola and Emissions(in percent) of Uruguay?
Give a very brief answer. -10.56. In the year 2003, what is the difference between the Emissions(in percent) in Saudi Arabia and Emissions(in percent) in Uruguay?
Your answer should be compact. -19.73. What is the ratio of the Emissions(in percent) in Middle income in 1997 to that in 1998?
Give a very brief answer. 0.97. What is the ratio of the Emissions(in percent) of Angola in 1997 to that in 1998?
Provide a short and direct response. 1.19. What is the ratio of the Emissions(in percent) of Saudi Arabia in 1997 to that in 1998?
Provide a short and direct response. 1.04. What is the ratio of the Emissions(in percent) in Uruguay in 1997 to that in 1998?
Your answer should be very brief. 1.01. What is the ratio of the Emissions(in percent) of Middle income in 1997 to that in 1999?
Your response must be concise. 0.96. What is the ratio of the Emissions(in percent) of Angola in 1997 to that in 1999?
Offer a very short reply. 1.11. What is the ratio of the Emissions(in percent) of Saudi Arabia in 1997 to that in 1999?
Make the answer very short. 0.96. What is the ratio of the Emissions(in percent) in Uruguay in 1997 to that in 1999?
Your answer should be very brief. 0.99. What is the ratio of the Emissions(in percent) in Middle income in 1997 to that in 2000?
Make the answer very short. 0.96. What is the ratio of the Emissions(in percent) in Angola in 1997 to that in 2000?
Provide a succinct answer. 1.17. What is the ratio of the Emissions(in percent) in Saudi Arabia in 1997 to that in 2000?
Your answer should be compact. 0.86. What is the ratio of the Emissions(in percent) of Uruguay in 1997 to that in 2000?
Offer a very short reply. 1.01. What is the ratio of the Emissions(in percent) in Middle income in 1997 to that in 2001?
Your answer should be very brief. 0.97. What is the ratio of the Emissions(in percent) in Angola in 1997 to that in 2001?
Your answer should be very brief. 1.02. What is the ratio of the Emissions(in percent) in Saudi Arabia in 1997 to that in 2001?
Keep it short and to the point. 0.83. What is the ratio of the Emissions(in percent) in Uruguay in 1997 to that in 2001?
Your answer should be very brief. 1.05. What is the ratio of the Emissions(in percent) in Angola in 1997 to that in 2002?
Offer a terse response. 1.14. What is the ratio of the Emissions(in percent) in Saudi Arabia in 1997 to that in 2002?
Your answer should be compact. 0.85. What is the ratio of the Emissions(in percent) in Uruguay in 1997 to that in 2002?
Your answer should be compact. 1.05. What is the ratio of the Emissions(in percent) in Middle income in 1997 to that in 2003?
Your answer should be compact. 1.07. What is the ratio of the Emissions(in percent) in Angola in 1997 to that in 2003?
Your response must be concise. 0.6. What is the ratio of the Emissions(in percent) in Saudi Arabia in 1997 to that in 2003?
Ensure brevity in your answer.  0.87. What is the ratio of the Emissions(in percent) of Uruguay in 1997 to that in 2003?
Offer a terse response. 1.08. What is the ratio of the Emissions(in percent) in Angola in 1998 to that in 1999?
Make the answer very short. 0.93. What is the ratio of the Emissions(in percent) of Saudi Arabia in 1998 to that in 1999?
Offer a terse response. 0.93. What is the ratio of the Emissions(in percent) of Uruguay in 1998 to that in 1999?
Offer a very short reply. 0.99. What is the ratio of the Emissions(in percent) in Middle income in 1998 to that in 2000?
Provide a succinct answer. 0.98. What is the ratio of the Emissions(in percent) in Angola in 1998 to that in 2000?
Your response must be concise. 0.98. What is the ratio of the Emissions(in percent) in Saudi Arabia in 1998 to that in 2000?
Provide a succinct answer. 0.83. What is the ratio of the Emissions(in percent) in Middle income in 1998 to that in 2001?
Provide a short and direct response. 0.99. What is the ratio of the Emissions(in percent) of Angola in 1998 to that in 2001?
Provide a succinct answer. 0.86. What is the ratio of the Emissions(in percent) of Saudi Arabia in 1998 to that in 2001?
Provide a short and direct response. 0.8. What is the ratio of the Emissions(in percent) in Uruguay in 1998 to that in 2001?
Your response must be concise. 1.04. What is the ratio of the Emissions(in percent) in Middle income in 1998 to that in 2002?
Make the answer very short. 1.03. What is the ratio of the Emissions(in percent) of Angola in 1998 to that in 2002?
Keep it short and to the point. 0.95. What is the ratio of the Emissions(in percent) in Saudi Arabia in 1998 to that in 2002?
Make the answer very short. 0.82. What is the ratio of the Emissions(in percent) of Uruguay in 1998 to that in 2002?
Offer a terse response. 1.04. What is the ratio of the Emissions(in percent) in Middle income in 1998 to that in 2003?
Provide a succinct answer. 1.1. What is the ratio of the Emissions(in percent) of Angola in 1998 to that in 2003?
Ensure brevity in your answer.  0.5. What is the ratio of the Emissions(in percent) of Saudi Arabia in 1998 to that in 2003?
Your answer should be very brief. 0.84. What is the ratio of the Emissions(in percent) of Uruguay in 1998 to that in 2003?
Offer a very short reply. 1.07. What is the ratio of the Emissions(in percent) of Middle income in 1999 to that in 2000?
Offer a terse response. 0.99. What is the ratio of the Emissions(in percent) in Angola in 1999 to that in 2000?
Provide a succinct answer. 1.05. What is the ratio of the Emissions(in percent) of Saudi Arabia in 1999 to that in 2000?
Your response must be concise. 0.89. What is the ratio of the Emissions(in percent) in Uruguay in 1999 to that in 2000?
Give a very brief answer. 1.01. What is the ratio of the Emissions(in percent) of Middle income in 1999 to that in 2001?
Make the answer very short. 1. What is the ratio of the Emissions(in percent) in Angola in 1999 to that in 2001?
Provide a succinct answer. 0.92. What is the ratio of the Emissions(in percent) in Saudi Arabia in 1999 to that in 2001?
Offer a terse response. 0.87. What is the ratio of the Emissions(in percent) in Uruguay in 1999 to that in 2001?
Your response must be concise. 1.05. What is the ratio of the Emissions(in percent) of Middle income in 1999 to that in 2002?
Give a very brief answer. 1.04. What is the ratio of the Emissions(in percent) in Angola in 1999 to that in 2002?
Provide a short and direct response. 1.02. What is the ratio of the Emissions(in percent) of Saudi Arabia in 1999 to that in 2002?
Your answer should be very brief. 0.89. What is the ratio of the Emissions(in percent) of Uruguay in 1999 to that in 2002?
Offer a terse response. 1.06. What is the ratio of the Emissions(in percent) in Middle income in 1999 to that in 2003?
Give a very brief answer. 1.11. What is the ratio of the Emissions(in percent) in Angola in 1999 to that in 2003?
Your answer should be very brief. 0.54. What is the ratio of the Emissions(in percent) of Saudi Arabia in 1999 to that in 2003?
Make the answer very short. 0.9. What is the ratio of the Emissions(in percent) in Uruguay in 1999 to that in 2003?
Your answer should be very brief. 1.09. What is the ratio of the Emissions(in percent) of Angola in 2000 to that in 2001?
Provide a succinct answer. 0.87. What is the ratio of the Emissions(in percent) of Saudi Arabia in 2000 to that in 2001?
Provide a succinct answer. 0.97. What is the ratio of the Emissions(in percent) in Uruguay in 2000 to that in 2001?
Keep it short and to the point. 1.04. What is the ratio of the Emissions(in percent) of Middle income in 2000 to that in 2002?
Offer a very short reply. 1.05. What is the ratio of the Emissions(in percent) of Angola in 2000 to that in 2002?
Your response must be concise. 0.97. What is the ratio of the Emissions(in percent) of Saudi Arabia in 2000 to that in 2002?
Offer a very short reply. 0.99. What is the ratio of the Emissions(in percent) in Uruguay in 2000 to that in 2002?
Your answer should be compact. 1.05. What is the ratio of the Emissions(in percent) of Middle income in 2000 to that in 2003?
Your answer should be very brief. 1.12. What is the ratio of the Emissions(in percent) in Angola in 2000 to that in 2003?
Offer a very short reply. 0.51. What is the ratio of the Emissions(in percent) in Saudi Arabia in 2000 to that in 2003?
Offer a very short reply. 1.01. What is the ratio of the Emissions(in percent) of Uruguay in 2000 to that in 2003?
Offer a very short reply. 1.07. What is the ratio of the Emissions(in percent) in Middle income in 2001 to that in 2002?
Your answer should be compact. 1.03. What is the ratio of the Emissions(in percent) of Angola in 2001 to that in 2002?
Give a very brief answer. 1.12. What is the ratio of the Emissions(in percent) in Saudi Arabia in 2001 to that in 2002?
Ensure brevity in your answer.  1.03. What is the ratio of the Emissions(in percent) in Middle income in 2001 to that in 2003?
Your answer should be compact. 1.1. What is the ratio of the Emissions(in percent) of Angola in 2001 to that in 2003?
Your answer should be very brief. 0.59. What is the ratio of the Emissions(in percent) in Saudi Arabia in 2001 to that in 2003?
Make the answer very short. 1.04. What is the ratio of the Emissions(in percent) in Uruguay in 2001 to that in 2003?
Give a very brief answer. 1.03. What is the ratio of the Emissions(in percent) of Middle income in 2002 to that in 2003?
Offer a very short reply. 1.07. What is the ratio of the Emissions(in percent) of Angola in 2002 to that in 2003?
Offer a very short reply. 0.53. What is the ratio of the Emissions(in percent) of Saudi Arabia in 2002 to that in 2003?
Offer a very short reply. 1.01. What is the ratio of the Emissions(in percent) of Uruguay in 2002 to that in 2003?
Your answer should be very brief. 1.03. What is the difference between the highest and the second highest Emissions(in percent) in Middle income?
Make the answer very short. 0.29. What is the difference between the highest and the second highest Emissions(in percent) in Angola?
Provide a short and direct response. 30.33. What is the difference between the highest and the second highest Emissions(in percent) in Saudi Arabia?
Provide a short and direct response. 1.74. What is the difference between the highest and the second highest Emissions(in percent) in Uruguay?
Provide a succinct answer. 0.69. What is the difference between the highest and the lowest Emissions(in percent) in Middle income?
Offer a terse response. 3.53. What is the difference between the highest and the lowest Emissions(in percent) of Angola?
Your answer should be very brief. 37.65. What is the difference between the highest and the lowest Emissions(in percent) in Saudi Arabia?
Make the answer very short. 13.65. What is the difference between the highest and the lowest Emissions(in percent) of Uruguay?
Your answer should be very brief. 7.52. 